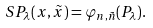<formula> <loc_0><loc_0><loc_500><loc_500>S P _ { \lambda } ( x , \tilde { x } ) = \varphi _ { n , \tilde { n } } ( P _ { \lambda } ) .</formula> 